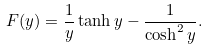<formula> <loc_0><loc_0><loc_500><loc_500>F ( y ) = \frac { 1 } { y } \tanh y - \frac { 1 } { \cosh ^ { 2 } y } .</formula> 